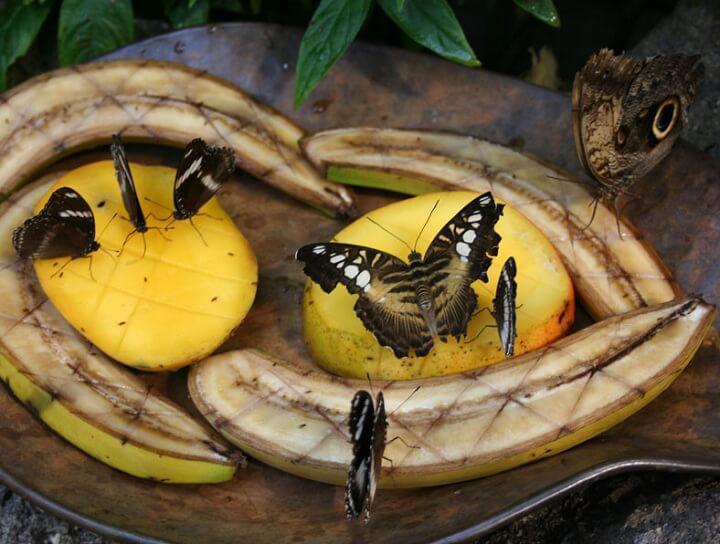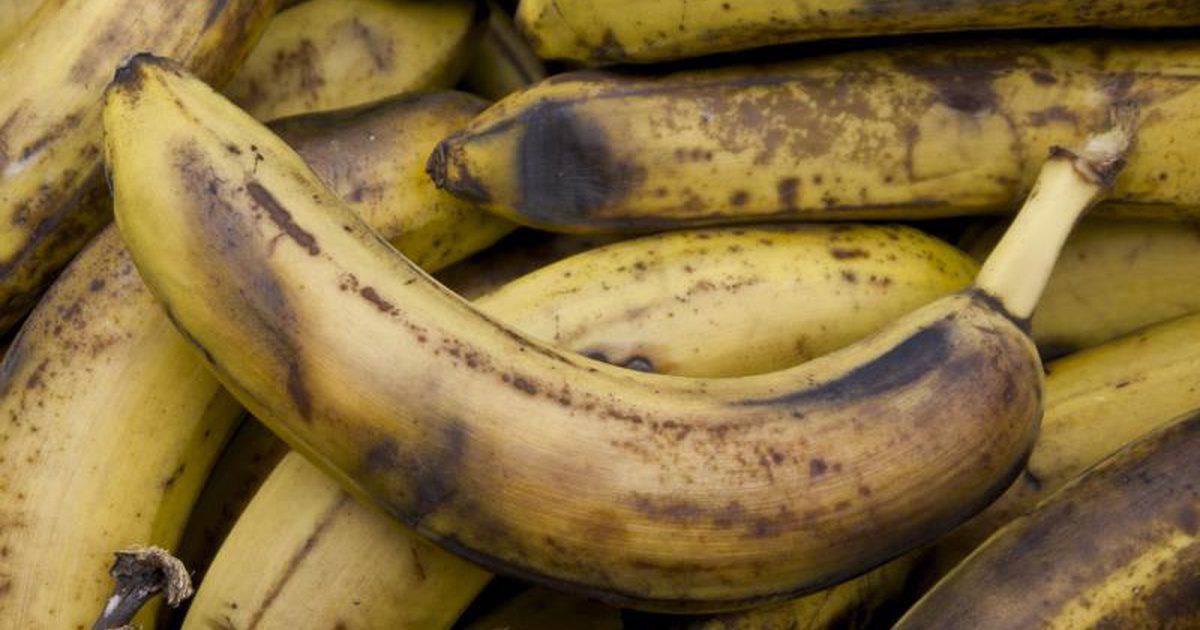The first image is the image on the left, the second image is the image on the right. Evaluate the accuracy of this statement regarding the images: "In the left image bananas are displayed with at least one other type of fruit.". Is it true? Answer yes or no. Yes. The first image is the image on the left, the second image is the image on the right. Given the left and right images, does the statement "The right image shows only overripe, brownish-yellow bananas with their peels intact, and the left image includes bananas and at least one other type of fruit." hold true? Answer yes or no. Yes. 